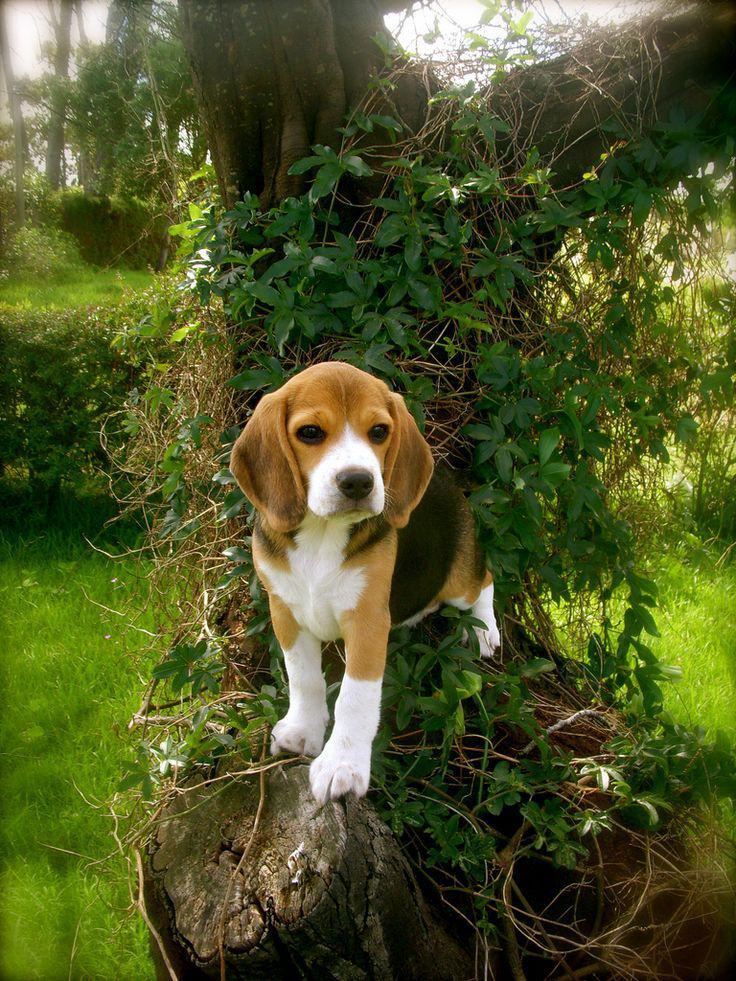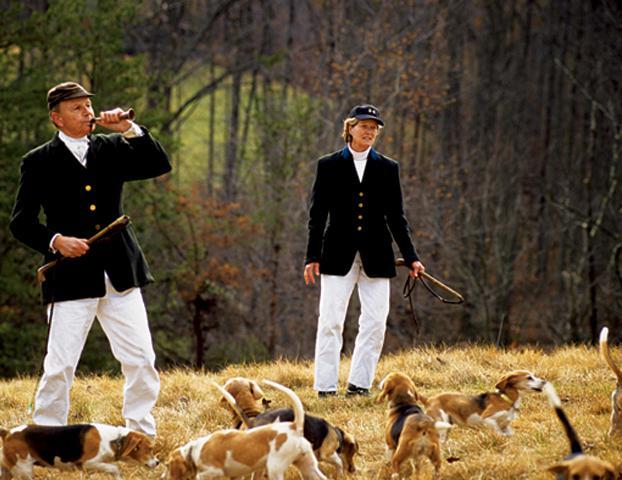The first image is the image on the left, the second image is the image on the right. Analyze the images presented: Is the assertion "An image shows two people wearing white trousers standing by a pack of hound dogs." valid? Answer yes or no. Yes. The first image is the image on the left, the second image is the image on the right. Considering the images on both sides, is "In one image, two people wearing white pants and dark tops, and carrying dog handling equipment are standing with a pack of dogs." valid? Answer yes or no. Yes. 